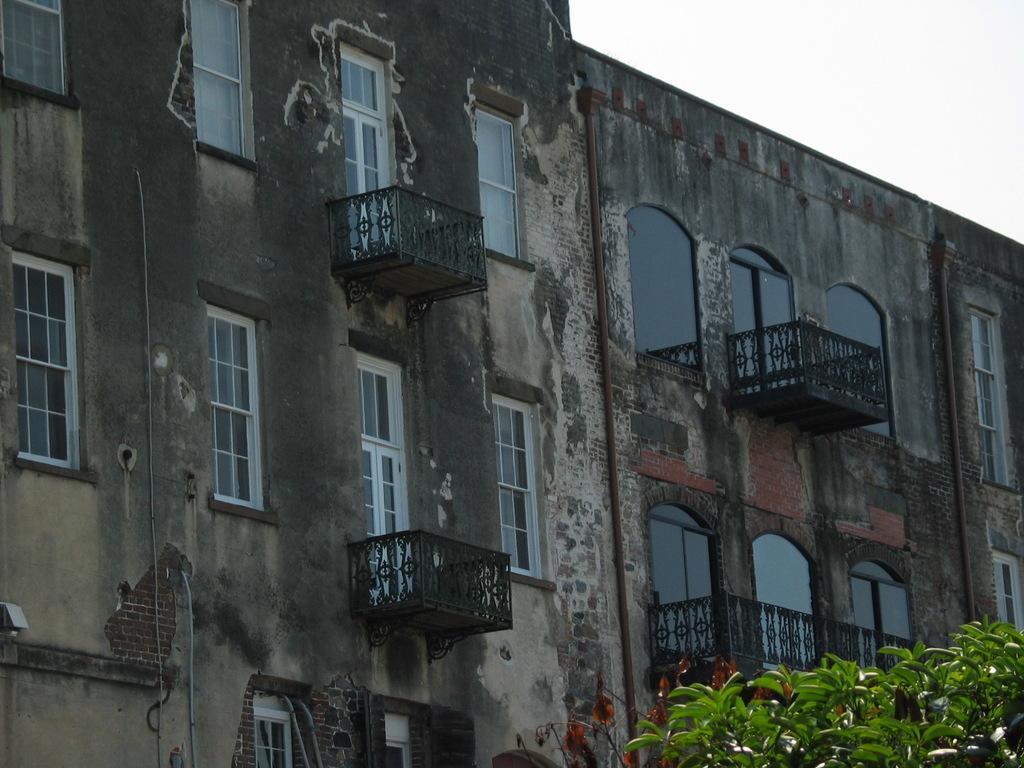How would you summarize this image in a sentence or two? In this picture we can see a building here, we can see glass windows, balconies and railings here, at the right bottom there are some leaves, we can see the sky at the right top of the picture. 